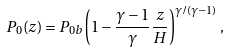Convert formula to latex. <formula><loc_0><loc_0><loc_500><loc_500>P _ { 0 } ( z ) = P _ { 0 b } \left ( 1 - \frac { \gamma - 1 } { \gamma } \frac { z } { H } \right ) ^ { \gamma / ( \gamma - 1 ) } ,</formula> 